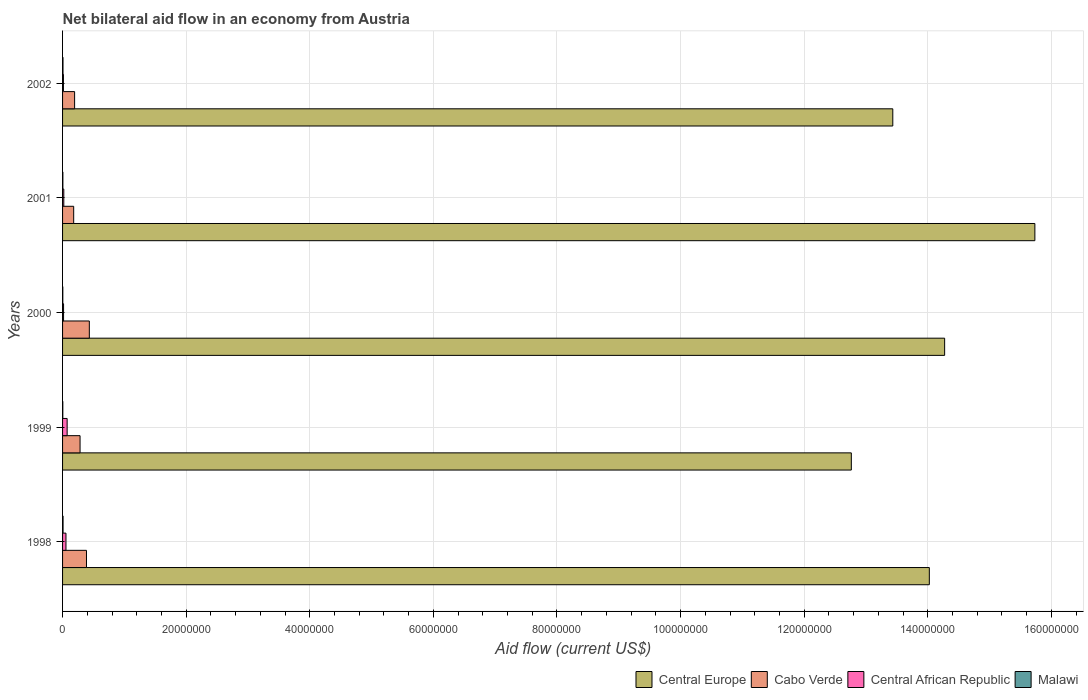How many different coloured bars are there?
Provide a succinct answer. 4. How many bars are there on the 1st tick from the top?
Keep it short and to the point. 4. How many bars are there on the 1st tick from the bottom?
Your answer should be compact. 4. Across all years, what is the maximum net bilateral aid flow in Central African Republic?
Provide a succinct answer. 7.40e+05. In which year was the net bilateral aid flow in Malawi maximum?
Provide a short and direct response. 1998. What is the total net bilateral aid flow in Central African Republic in the graph?
Your answer should be very brief. 1.79e+06. What is the difference between the net bilateral aid flow in Central African Republic in 1999 and that in 2000?
Ensure brevity in your answer.  5.80e+05. What is the average net bilateral aid flow in Malawi per year?
Provide a succinct answer. 5.60e+04. In the year 1998, what is the difference between the net bilateral aid flow in Cabo Verde and net bilateral aid flow in Malawi?
Your answer should be very brief. 3.79e+06. In how many years, is the net bilateral aid flow in Central Europe greater than 76000000 US$?
Your answer should be very brief. 5. What is the ratio of the net bilateral aid flow in Central African Republic in 2001 to that in 2002?
Offer a terse response. 1.43. Is the net bilateral aid flow in Cabo Verde in 1998 less than that in 2001?
Keep it short and to the point. No. What is the difference between the highest and the second highest net bilateral aid flow in Central Europe?
Provide a short and direct response. 1.46e+07. What is the difference between the highest and the lowest net bilateral aid flow in Malawi?
Give a very brief answer. 4.00e+04. Is it the case that in every year, the sum of the net bilateral aid flow in Cabo Verde and net bilateral aid flow in Central African Republic is greater than the sum of net bilateral aid flow in Central Europe and net bilateral aid flow in Malawi?
Your answer should be very brief. Yes. What does the 4th bar from the top in 1999 represents?
Ensure brevity in your answer.  Central Europe. What does the 3rd bar from the bottom in 1998 represents?
Your answer should be compact. Central African Republic. Does the graph contain grids?
Your response must be concise. Yes. Where does the legend appear in the graph?
Your response must be concise. Bottom right. How many legend labels are there?
Give a very brief answer. 4. What is the title of the graph?
Your answer should be very brief. Net bilateral aid flow in an economy from Austria. What is the label or title of the X-axis?
Offer a terse response. Aid flow (current US$). What is the Aid flow (current US$) in Central Europe in 1998?
Your answer should be very brief. 1.40e+08. What is the Aid flow (current US$) of Cabo Verde in 1998?
Your response must be concise. 3.87e+06. What is the Aid flow (current US$) of Central African Republic in 1998?
Ensure brevity in your answer.  5.50e+05. What is the Aid flow (current US$) of Malawi in 1998?
Ensure brevity in your answer.  8.00e+04. What is the Aid flow (current US$) in Central Europe in 1999?
Offer a terse response. 1.28e+08. What is the Aid flow (current US$) of Cabo Verde in 1999?
Give a very brief answer. 2.83e+06. What is the Aid flow (current US$) of Central African Republic in 1999?
Your answer should be very brief. 7.40e+05. What is the Aid flow (current US$) in Central Europe in 2000?
Provide a short and direct response. 1.43e+08. What is the Aid flow (current US$) of Cabo Verde in 2000?
Provide a succinct answer. 4.33e+06. What is the Aid flow (current US$) in Malawi in 2000?
Your answer should be compact. 4.00e+04. What is the Aid flow (current US$) in Central Europe in 2001?
Give a very brief answer. 1.57e+08. What is the Aid flow (current US$) of Cabo Verde in 2001?
Offer a very short reply. 1.80e+06. What is the Aid flow (current US$) in Central Europe in 2002?
Provide a succinct answer. 1.34e+08. What is the Aid flow (current US$) of Cabo Verde in 2002?
Your response must be concise. 1.95e+06. What is the Aid flow (current US$) of Malawi in 2002?
Give a very brief answer. 7.00e+04. Across all years, what is the maximum Aid flow (current US$) of Central Europe?
Offer a very short reply. 1.57e+08. Across all years, what is the maximum Aid flow (current US$) in Cabo Verde?
Make the answer very short. 4.33e+06. Across all years, what is the maximum Aid flow (current US$) in Central African Republic?
Keep it short and to the point. 7.40e+05. Across all years, what is the minimum Aid flow (current US$) of Central Europe?
Ensure brevity in your answer.  1.28e+08. Across all years, what is the minimum Aid flow (current US$) in Cabo Verde?
Offer a terse response. 1.80e+06. Across all years, what is the minimum Aid flow (current US$) of Malawi?
Offer a terse response. 4.00e+04. What is the total Aid flow (current US$) in Central Europe in the graph?
Keep it short and to the point. 7.02e+08. What is the total Aid flow (current US$) of Cabo Verde in the graph?
Your answer should be compact. 1.48e+07. What is the total Aid flow (current US$) of Central African Republic in the graph?
Your answer should be compact. 1.79e+06. What is the total Aid flow (current US$) in Malawi in the graph?
Your answer should be very brief. 2.80e+05. What is the difference between the Aid flow (current US$) of Central Europe in 1998 and that in 1999?
Offer a terse response. 1.26e+07. What is the difference between the Aid flow (current US$) of Cabo Verde in 1998 and that in 1999?
Your response must be concise. 1.04e+06. What is the difference between the Aid flow (current US$) of Central Europe in 1998 and that in 2000?
Provide a short and direct response. -2.48e+06. What is the difference between the Aid flow (current US$) of Cabo Verde in 1998 and that in 2000?
Provide a short and direct response. -4.60e+05. What is the difference between the Aid flow (current US$) in Central Europe in 1998 and that in 2001?
Give a very brief answer. -1.71e+07. What is the difference between the Aid flow (current US$) of Cabo Verde in 1998 and that in 2001?
Your response must be concise. 2.07e+06. What is the difference between the Aid flow (current US$) of Central African Republic in 1998 and that in 2001?
Your response must be concise. 3.50e+05. What is the difference between the Aid flow (current US$) of Central Europe in 1998 and that in 2002?
Make the answer very short. 5.91e+06. What is the difference between the Aid flow (current US$) in Cabo Verde in 1998 and that in 2002?
Provide a succinct answer. 1.92e+06. What is the difference between the Aid flow (current US$) in Central African Republic in 1998 and that in 2002?
Ensure brevity in your answer.  4.10e+05. What is the difference between the Aid flow (current US$) of Central Europe in 1999 and that in 2000?
Offer a terse response. -1.51e+07. What is the difference between the Aid flow (current US$) of Cabo Verde in 1999 and that in 2000?
Keep it short and to the point. -1.50e+06. What is the difference between the Aid flow (current US$) in Central African Republic in 1999 and that in 2000?
Make the answer very short. 5.80e+05. What is the difference between the Aid flow (current US$) of Central Europe in 1999 and that in 2001?
Your answer should be compact. -2.97e+07. What is the difference between the Aid flow (current US$) in Cabo Verde in 1999 and that in 2001?
Your response must be concise. 1.03e+06. What is the difference between the Aid flow (current US$) of Central African Republic in 1999 and that in 2001?
Your response must be concise. 5.40e+05. What is the difference between the Aid flow (current US$) of Central Europe in 1999 and that in 2002?
Make the answer very short. -6.71e+06. What is the difference between the Aid flow (current US$) of Cabo Verde in 1999 and that in 2002?
Your answer should be compact. 8.80e+05. What is the difference between the Aid flow (current US$) of Central African Republic in 1999 and that in 2002?
Offer a very short reply. 6.00e+05. What is the difference between the Aid flow (current US$) of Central Europe in 2000 and that in 2001?
Provide a short and direct response. -1.46e+07. What is the difference between the Aid flow (current US$) in Cabo Verde in 2000 and that in 2001?
Your response must be concise. 2.53e+06. What is the difference between the Aid flow (current US$) of Central African Republic in 2000 and that in 2001?
Offer a very short reply. -4.00e+04. What is the difference between the Aid flow (current US$) in Central Europe in 2000 and that in 2002?
Provide a short and direct response. 8.39e+06. What is the difference between the Aid flow (current US$) of Cabo Verde in 2000 and that in 2002?
Keep it short and to the point. 2.38e+06. What is the difference between the Aid flow (current US$) in Central Europe in 2001 and that in 2002?
Offer a very short reply. 2.30e+07. What is the difference between the Aid flow (current US$) of Cabo Verde in 2001 and that in 2002?
Offer a very short reply. -1.50e+05. What is the difference between the Aid flow (current US$) of Malawi in 2001 and that in 2002?
Your answer should be very brief. -2.00e+04. What is the difference between the Aid flow (current US$) in Central Europe in 1998 and the Aid flow (current US$) in Cabo Verde in 1999?
Make the answer very short. 1.37e+08. What is the difference between the Aid flow (current US$) of Central Europe in 1998 and the Aid flow (current US$) of Central African Republic in 1999?
Give a very brief answer. 1.40e+08. What is the difference between the Aid flow (current US$) of Central Europe in 1998 and the Aid flow (current US$) of Malawi in 1999?
Your response must be concise. 1.40e+08. What is the difference between the Aid flow (current US$) of Cabo Verde in 1998 and the Aid flow (current US$) of Central African Republic in 1999?
Provide a short and direct response. 3.13e+06. What is the difference between the Aid flow (current US$) of Cabo Verde in 1998 and the Aid flow (current US$) of Malawi in 1999?
Your answer should be compact. 3.83e+06. What is the difference between the Aid flow (current US$) of Central African Republic in 1998 and the Aid flow (current US$) of Malawi in 1999?
Your response must be concise. 5.10e+05. What is the difference between the Aid flow (current US$) in Central Europe in 1998 and the Aid flow (current US$) in Cabo Verde in 2000?
Give a very brief answer. 1.36e+08. What is the difference between the Aid flow (current US$) of Central Europe in 1998 and the Aid flow (current US$) of Central African Republic in 2000?
Provide a succinct answer. 1.40e+08. What is the difference between the Aid flow (current US$) in Central Europe in 1998 and the Aid flow (current US$) in Malawi in 2000?
Provide a short and direct response. 1.40e+08. What is the difference between the Aid flow (current US$) in Cabo Verde in 1998 and the Aid flow (current US$) in Central African Republic in 2000?
Your answer should be compact. 3.71e+06. What is the difference between the Aid flow (current US$) of Cabo Verde in 1998 and the Aid flow (current US$) of Malawi in 2000?
Your answer should be compact. 3.83e+06. What is the difference between the Aid flow (current US$) in Central African Republic in 1998 and the Aid flow (current US$) in Malawi in 2000?
Provide a short and direct response. 5.10e+05. What is the difference between the Aid flow (current US$) in Central Europe in 1998 and the Aid flow (current US$) in Cabo Verde in 2001?
Provide a short and direct response. 1.38e+08. What is the difference between the Aid flow (current US$) in Central Europe in 1998 and the Aid flow (current US$) in Central African Republic in 2001?
Provide a succinct answer. 1.40e+08. What is the difference between the Aid flow (current US$) in Central Europe in 1998 and the Aid flow (current US$) in Malawi in 2001?
Ensure brevity in your answer.  1.40e+08. What is the difference between the Aid flow (current US$) in Cabo Verde in 1998 and the Aid flow (current US$) in Central African Republic in 2001?
Ensure brevity in your answer.  3.67e+06. What is the difference between the Aid flow (current US$) in Cabo Verde in 1998 and the Aid flow (current US$) in Malawi in 2001?
Make the answer very short. 3.82e+06. What is the difference between the Aid flow (current US$) of Central Europe in 1998 and the Aid flow (current US$) of Cabo Verde in 2002?
Provide a succinct answer. 1.38e+08. What is the difference between the Aid flow (current US$) in Central Europe in 1998 and the Aid flow (current US$) in Central African Republic in 2002?
Provide a short and direct response. 1.40e+08. What is the difference between the Aid flow (current US$) in Central Europe in 1998 and the Aid flow (current US$) in Malawi in 2002?
Give a very brief answer. 1.40e+08. What is the difference between the Aid flow (current US$) of Cabo Verde in 1998 and the Aid flow (current US$) of Central African Republic in 2002?
Your answer should be very brief. 3.73e+06. What is the difference between the Aid flow (current US$) in Cabo Verde in 1998 and the Aid flow (current US$) in Malawi in 2002?
Provide a short and direct response. 3.80e+06. What is the difference between the Aid flow (current US$) of Central African Republic in 1998 and the Aid flow (current US$) of Malawi in 2002?
Make the answer very short. 4.80e+05. What is the difference between the Aid flow (current US$) in Central Europe in 1999 and the Aid flow (current US$) in Cabo Verde in 2000?
Give a very brief answer. 1.23e+08. What is the difference between the Aid flow (current US$) of Central Europe in 1999 and the Aid flow (current US$) of Central African Republic in 2000?
Your response must be concise. 1.27e+08. What is the difference between the Aid flow (current US$) in Central Europe in 1999 and the Aid flow (current US$) in Malawi in 2000?
Your answer should be very brief. 1.28e+08. What is the difference between the Aid flow (current US$) of Cabo Verde in 1999 and the Aid flow (current US$) of Central African Republic in 2000?
Make the answer very short. 2.67e+06. What is the difference between the Aid flow (current US$) in Cabo Verde in 1999 and the Aid flow (current US$) in Malawi in 2000?
Your answer should be very brief. 2.79e+06. What is the difference between the Aid flow (current US$) of Central Europe in 1999 and the Aid flow (current US$) of Cabo Verde in 2001?
Your response must be concise. 1.26e+08. What is the difference between the Aid flow (current US$) of Central Europe in 1999 and the Aid flow (current US$) of Central African Republic in 2001?
Give a very brief answer. 1.27e+08. What is the difference between the Aid flow (current US$) of Central Europe in 1999 and the Aid flow (current US$) of Malawi in 2001?
Offer a very short reply. 1.28e+08. What is the difference between the Aid flow (current US$) of Cabo Verde in 1999 and the Aid flow (current US$) of Central African Republic in 2001?
Provide a short and direct response. 2.63e+06. What is the difference between the Aid flow (current US$) of Cabo Verde in 1999 and the Aid flow (current US$) of Malawi in 2001?
Your answer should be compact. 2.78e+06. What is the difference between the Aid flow (current US$) of Central African Republic in 1999 and the Aid flow (current US$) of Malawi in 2001?
Provide a succinct answer. 6.90e+05. What is the difference between the Aid flow (current US$) of Central Europe in 1999 and the Aid flow (current US$) of Cabo Verde in 2002?
Provide a succinct answer. 1.26e+08. What is the difference between the Aid flow (current US$) of Central Europe in 1999 and the Aid flow (current US$) of Central African Republic in 2002?
Your response must be concise. 1.27e+08. What is the difference between the Aid flow (current US$) in Central Europe in 1999 and the Aid flow (current US$) in Malawi in 2002?
Make the answer very short. 1.28e+08. What is the difference between the Aid flow (current US$) of Cabo Verde in 1999 and the Aid flow (current US$) of Central African Republic in 2002?
Offer a very short reply. 2.69e+06. What is the difference between the Aid flow (current US$) in Cabo Verde in 1999 and the Aid flow (current US$) in Malawi in 2002?
Your answer should be compact. 2.76e+06. What is the difference between the Aid flow (current US$) in Central African Republic in 1999 and the Aid flow (current US$) in Malawi in 2002?
Offer a terse response. 6.70e+05. What is the difference between the Aid flow (current US$) of Central Europe in 2000 and the Aid flow (current US$) of Cabo Verde in 2001?
Give a very brief answer. 1.41e+08. What is the difference between the Aid flow (current US$) of Central Europe in 2000 and the Aid flow (current US$) of Central African Republic in 2001?
Provide a succinct answer. 1.43e+08. What is the difference between the Aid flow (current US$) in Central Europe in 2000 and the Aid flow (current US$) in Malawi in 2001?
Your response must be concise. 1.43e+08. What is the difference between the Aid flow (current US$) in Cabo Verde in 2000 and the Aid flow (current US$) in Central African Republic in 2001?
Make the answer very short. 4.13e+06. What is the difference between the Aid flow (current US$) of Cabo Verde in 2000 and the Aid flow (current US$) of Malawi in 2001?
Ensure brevity in your answer.  4.28e+06. What is the difference between the Aid flow (current US$) in Central African Republic in 2000 and the Aid flow (current US$) in Malawi in 2001?
Your answer should be very brief. 1.10e+05. What is the difference between the Aid flow (current US$) in Central Europe in 2000 and the Aid flow (current US$) in Cabo Verde in 2002?
Offer a very short reply. 1.41e+08. What is the difference between the Aid flow (current US$) in Central Europe in 2000 and the Aid flow (current US$) in Central African Republic in 2002?
Ensure brevity in your answer.  1.43e+08. What is the difference between the Aid flow (current US$) in Central Europe in 2000 and the Aid flow (current US$) in Malawi in 2002?
Make the answer very short. 1.43e+08. What is the difference between the Aid flow (current US$) of Cabo Verde in 2000 and the Aid flow (current US$) of Central African Republic in 2002?
Provide a succinct answer. 4.19e+06. What is the difference between the Aid flow (current US$) of Cabo Verde in 2000 and the Aid flow (current US$) of Malawi in 2002?
Ensure brevity in your answer.  4.26e+06. What is the difference between the Aid flow (current US$) in Central African Republic in 2000 and the Aid flow (current US$) in Malawi in 2002?
Keep it short and to the point. 9.00e+04. What is the difference between the Aid flow (current US$) of Central Europe in 2001 and the Aid flow (current US$) of Cabo Verde in 2002?
Your answer should be very brief. 1.55e+08. What is the difference between the Aid flow (current US$) in Central Europe in 2001 and the Aid flow (current US$) in Central African Republic in 2002?
Provide a short and direct response. 1.57e+08. What is the difference between the Aid flow (current US$) of Central Europe in 2001 and the Aid flow (current US$) of Malawi in 2002?
Provide a succinct answer. 1.57e+08. What is the difference between the Aid flow (current US$) in Cabo Verde in 2001 and the Aid flow (current US$) in Central African Republic in 2002?
Ensure brevity in your answer.  1.66e+06. What is the difference between the Aid flow (current US$) in Cabo Verde in 2001 and the Aid flow (current US$) in Malawi in 2002?
Make the answer very short. 1.73e+06. What is the average Aid flow (current US$) of Central Europe per year?
Keep it short and to the point. 1.40e+08. What is the average Aid flow (current US$) in Cabo Verde per year?
Offer a very short reply. 2.96e+06. What is the average Aid flow (current US$) of Central African Republic per year?
Keep it short and to the point. 3.58e+05. What is the average Aid flow (current US$) in Malawi per year?
Your answer should be very brief. 5.60e+04. In the year 1998, what is the difference between the Aid flow (current US$) in Central Europe and Aid flow (current US$) in Cabo Verde?
Give a very brief answer. 1.36e+08. In the year 1998, what is the difference between the Aid flow (current US$) of Central Europe and Aid flow (current US$) of Central African Republic?
Your response must be concise. 1.40e+08. In the year 1998, what is the difference between the Aid flow (current US$) of Central Europe and Aid flow (current US$) of Malawi?
Give a very brief answer. 1.40e+08. In the year 1998, what is the difference between the Aid flow (current US$) in Cabo Verde and Aid flow (current US$) in Central African Republic?
Your answer should be very brief. 3.32e+06. In the year 1998, what is the difference between the Aid flow (current US$) in Cabo Verde and Aid flow (current US$) in Malawi?
Your answer should be very brief. 3.79e+06. In the year 1998, what is the difference between the Aid flow (current US$) in Central African Republic and Aid flow (current US$) in Malawi?
Make the answer very short. 4.70e+05. In the year 1999, what is the difference between the Aid flow (current US$) of Central Europe and Aid flow (current US$) of Cabo Verde?
Keep it short and to the point. 1.25e+08. In the year 1999, what is the difference between the Aid flow (current US$) in Central Europe and Aid flow (current US$) in Central African Republic?
Offer a very short reply. 1.27e+08. In the year 1999, what is the difference between the Aid flow (current US$) of Central Europe and Aid flow (current US$) of Malawi?
Your response must be concise. 1.28e+08. In the year 1999, what is the difference between the Aid flow (current US$) in Cabo Verde and Aid flow (current US$) in Central African Republic?
Make the answer very short. 2.09e+06. In the year 1999, what is the difference between the Aid flow (current US$) in Cabo Verde and Aid flow (current US$) in Malawi?
Give a very brief answer. 2.79e+06. In the year 2000, what is the difference between the Aid flow (current US$) in Central Europe and Aid flow (current US$) in Cabo Verde?
Offer a very short reply. 1.38e+08. In the year 2000, what is the difference between the Aid flow (current US$) of Central Europe and Aid flow (current US$) of Central African Republic?
Give a very brief answer. 1.43e+08. In the year 2000, what is the difference between the Aid flow (current US$) of Central Europe and Aid flow (current US$) of Malawi?
Keep it short and to the point. 1.43e+08. In the year 2000, what is the difference between the Aid flow (current US$) of Cabo Verde and Aid flow (current US$) of Central African Republic?
Provide a succinct answer. 4.17e+06. In the year 2000, what is the difference between the Aid flow (current US$) of Cabo Verde and Aid flow (current US$) of Malawi?
Offer a terse response. 4.29e+06. In the year 2000, what is the difference between the Aid flow (current US$) of Central African Republic and Aid flow (current US$) of Malawi?
Give a very brief answer. 1.20e+05. In the year 2001, what is the difference between the Aid flow (current US$) of Central Europe and Aid flow (current US$) of Cabo Verde?
Give a very brief answer. 1.56e+08. In the year 2001, what is the difference between the Aid flow (current US$) in Central Europe and Aid flow (current US$) in Central African Republic?
Keep it short and to the point. 1.57e+08. In the year 2001, what is the difference between the Aid flow (current US$) of Central Europe and Aid flow (current US$) of Malawi?
Your response must be concise. 1.57e+08. In the year 2001, what is the difference between the Aid flow (current US$) of Cabo Verde and Aid flow (current US$) of Central African Republic?
Make the answer very short. 1.60e+06. In the year 2001, what is the difference between the Aid flow (current US$) in Cabo Verde and Aid flow (current US$) in Malawi?
Provide a succinct answer. 1.75e+06. In the year 2001, what is the difference between the Aid flow (current US$) of Central African Republic and Aid flow (current US$) of Malawi?
Your answer should be compact. 1.50e+05. In the year 2002, what is the difference between the Aid flow (current US$) in Central Europe and Aid flow (current US$) in Cabo Verde?
Give a very brief answer. 1.32e+08. In the year 2002, what is the difference between the Aid flow (current US$) of Central Europe and Aid flow (current US$) of Central African Republic?
Your response must be concise. 1.34e+08. In the year 2002, what is the difference between the Aid flow (current US$) of Central Europe and Aid flow (current US$) of Malawi?
Make the answer very short. 1.34e+08. In the year 2002, what is the difference between the Aid flow (current US$) of Cabo Verde and Aid flow (current US$) of Central African Republic?
Ensure brevity in your answer.  1.81e+06. In the year 2002, what is the difference between the Aid flow (current US$) in Cabo Verde and Aid flow (current US$) in Malawi?
Your response must be concise. 1.88e+06. What is the ratio of the Aid flow (current US$) of Central Europe in 1998 to that in 1999?
Keep it short and to the point. 1.1. What is the ratio of the Aid flow (current US$) in Cabo Verde in 1998 to that in 1999?
Provide a succinct answer. 1.37. What is the ratio of the Aid flow (current US$) of Central African Republic in 1998 to that in 1999?
Keep it short and to the point. 0.74. What is the ratio of the Aid flow (current US$) of Malawi in 1998 to that in 1999?
Your response must be concise. 2. What is the ratio of the Aid flow (current US$) in Central Europe in 1998 to that in 2000?
Your answer should be very brief. 0.98. What is the ratio of the Aid flow (current US$) of Cabo Verde in 1998 to that in 2000?
Provide a succinct answer. 0.89. What is the ratio of the Aid flow (current US$) in Central African Republic in 1998 to that in 2000?
Keep it short and to the point. 3.44. What is the ratio of the Aid flow (current US$) in Malawi in 1998 to that in 2000?
Give a very brief answer. 2. What is the ratio of the Aid flow (current US$) in Central Europe in 1998 to that in 2001?
Give a very brief answer. 0.89. What is the ratio of the Aid flow (current US$) of Cabo Verde in 1998 to that in 2001?
Your answer should be very brief. 2.15. What is the ratio of the Aid flow (current US$) in Central African Republic in 1998 to that in 2001?
Make the answer very short. 2.75. What is the ratio of the Aid flow (current US$) in Central Europe in 1998 to that in 2002?
Provide a short and direct response. 1.04. What is the ratio of the Aid flow (current US$) of Cabo Verde in 1998 to that in 2002?
Offer a very short reply. 1.98. What is the ratio of the Aid flow (current US$) in Central African Republic in 1998 to that in 2002?
Your answer should be very brief. 3.93. What is the ratio of the Aid flow (current US$) in Malawi in 1998 to that in 2002?
Your answer should be compact. 1.14. What is the ratio of the Aid flow (current US$) in Central Europe in 1999 to that in 2000?
Give a very brief answer. 0.89. What is the ratio of the Aid flow (current US$) in Cabo Verde in 1999 to that in 2000?
Keep it short and to the point. 0.65. What is the ratio of the Aid flow (current US$) of Central African Republic in 1999 to that in 2000?
Ensure brevity in your answer.  4.62. What is the ratio of the Aid flow (current US$) of Central Europe in 1999 to that in 2001?
Your answer should be very brief. 0.81. What is the ratio of the Aid flow (current US$) of Cabo Verde in 1999 to that in 2001?
Make the answer very short. 1.57. What is the ratio of the Aid flow (current US$) of Malawi in 1999 to that in 2001?
Your answer should be very brief. 0.8. What is the ratio of the Aid flow (current US$) of Central Europe in 1999 to that in 2002?
Offer a terse response. 0.95. What is the ratio of the Aid flow (current US$) in Cabo Verde in 1999 to that in 2002?
Keep it short and to the point. 1.45. What is the ratio of the Aid flow (current US$) of Central African Republic in 1999 to that in 2002?
Keep it short and to the point. 5.29. What is the ratio of the Aid flow (current US$) of Central Europe in 2000 to that in 2001?
Keep it short and to the point. 0.91. What is the ratio of the Aid flow (current US$) of Cabo Verde in 2000 to that in 2001?
Your answer should be compact. 2.41. What is the ratio of the Aid flow (current US$) in Central African Republic in 2000 to that in 2001?
Ensure brevity in your answer.  0.8. What is the ratio of the Aid flow (current US$) in Cabo Verde in 2000 to that in 2002?
Provide a short and direct response. 2.22. What is the ratio of the Aid flow (current US$) in Central African Republic in 2000 to that in 2002?
Provide a succinct answer. 1.14. What is the ratio of the Aid flow (current US$) in Central Europe in 2001 to that in 2002?
Your answer should be very brief. 1.17. What is the ratio of the Aid flow (current US$) of Central African Republic in 2001 to that in 2002?
Ensure brevity in your answer.  1.43. What is the difference between the highest and the second highest Aid flow (current US$) of Central Europe?
Give a very brief answer. 1.46e+07. What is the difference between the highest and the second highest Aid flow (current US$) in Cabo Verde?
Your answer should be compact. 4.60e+05. What is the difference between the highest and the lowest Aid flow (current US$) in Central Europe?
Offer a terse response. 2.97e+07. What is the difference between the highest and the lowest Aid flow (current US$) in Cabo Verde?
Keep it short and to the point. 2.53e+06. What is the difference between the highest and the lowest Aid flow (current US$) in Central African Republic?
Give a very brief answer. 6.00e+05. What is the difference between the highest and the lowest Aid flow (current US$) of Malawi?
Offer a terse response. 4.00e+04. 